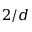<formula> <loc_0><loc_0><loc_500><loc_500>2 / d</formula> 